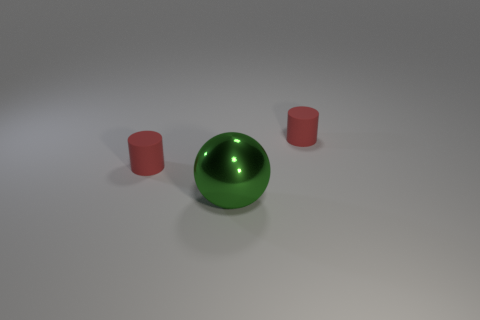Add 1 green objects. How many objects exist? 4 Subtract all cylinders. How many objects are left? 1 Add 1 gray shiny blocks. How many gray shiny blocks exist? 1 Subtract 0 red balls. How many objects are left? 3 Subtract all yellow spheres. Subtract all purple cylinders. How many spheres are left? 1 Subtract all balls. Subtract all tiny green blocks. How many objects are left? 2 Add 3 tiny red cylinders. How many tiny red cylinders are left? 5 